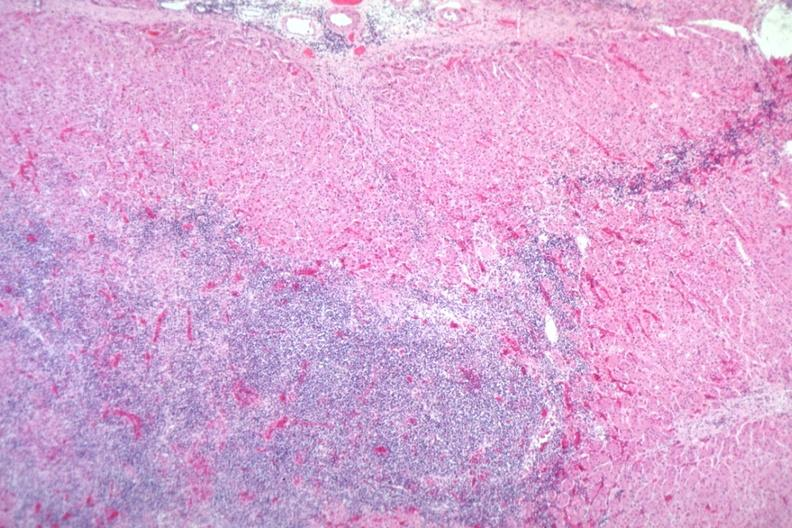s endocrine present?
Answer the question using a single word or phrase. Yes 